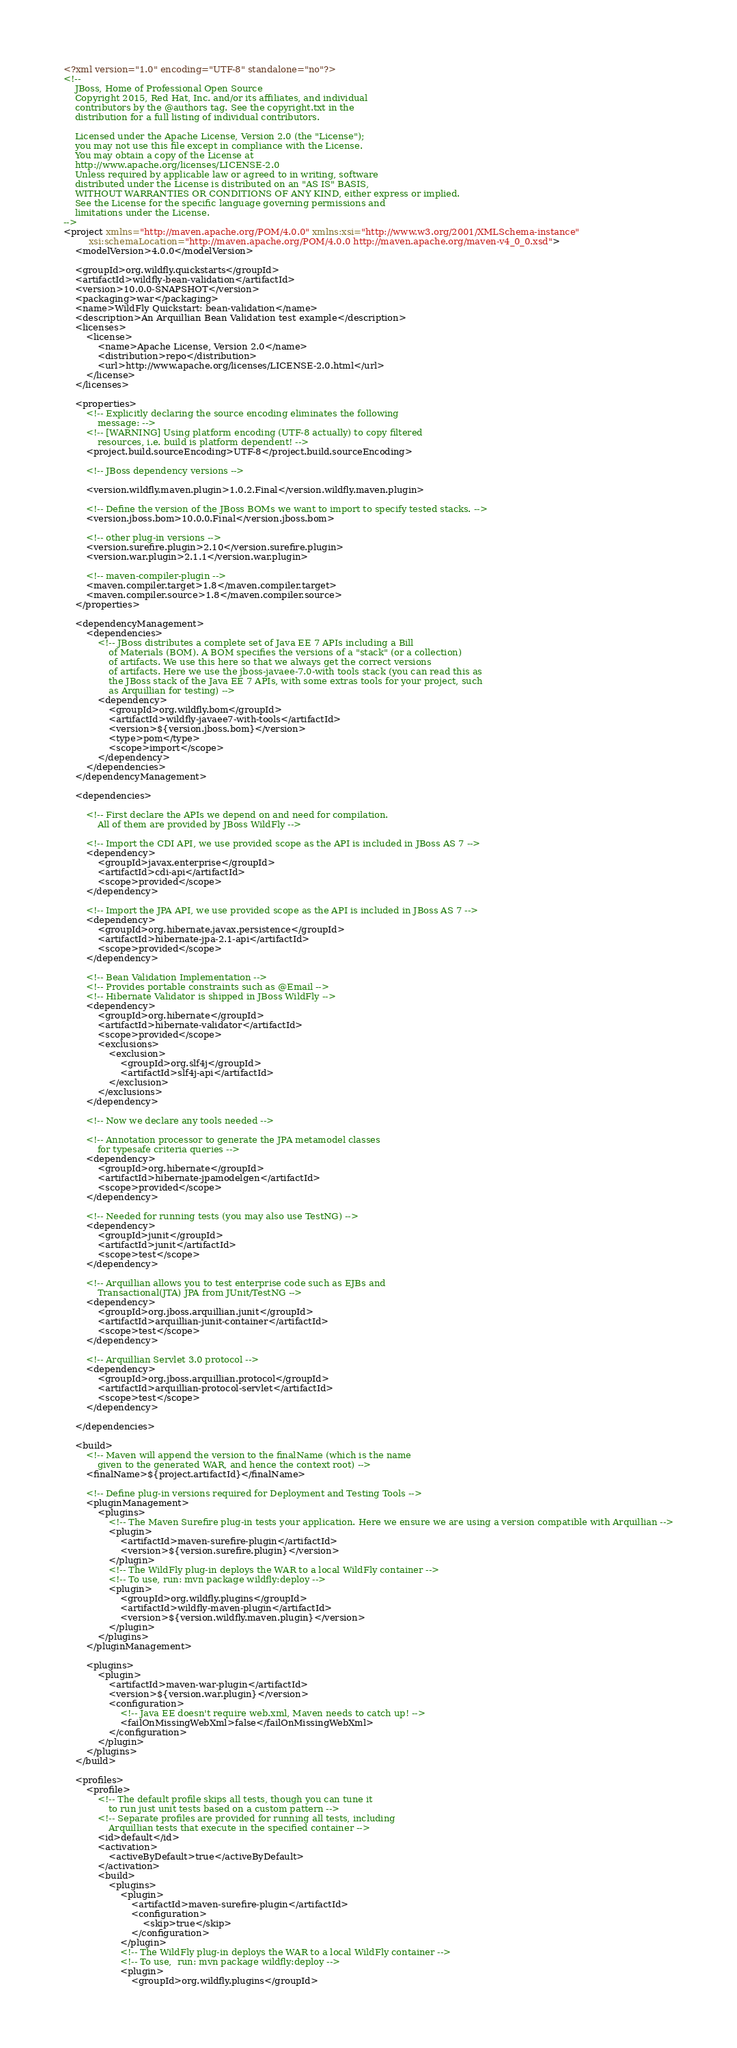<code> <loc_0><loc_0><loc_500><loc_500><_XML_><?xml version="1.0" encoding="UTF-8" standalone="no"?>
<!--
    JBoss, Home of Professional Open Source
    Copyright 2015, Red Hat, Inc. and/or its affiliates, and individual
    contributors by the @authors tag. See the copyright.txt in the
    distribution for a full listing of individual contributors.

    Licensed under the Apache License, Version 2.0 (the "License");
    you may not use this file except in compliance with the License.
    You may obtain a copy of the License at
    http://www.apache.org/licenses/LICENSE-2.0
    Unless required by applicable law or agreed to in writing, software
    distributed under the License is distributed on an "AS IS" BASIS,
    WITHOUT WARRANTIES OR CONDITIONS OF ANY KIND, either express or implied.
    See the License for the specific language governing permissions and
    limitations under the License.
-->
<project xmlns="http://maven.apache.org/POM/4.0.0" xmlns:xsi="http://www.w3.org/2001/XMLSchema-instance"
         xsi:schemaLocation="http://maven.apache.org/POM/4.0.0 http://maven.apache.org/maven-v4_0_0.xsd">
    <modelVersion>4.0.0</modelVersion>

    <groupId>org.wildfly.quickstarts</groupId>
    <artifactId>wildfly-bean-validation</artifactId>
    <version>10.0.0-SNAPSHOT</version>
    <packaging>war</packaging>
    <name>WildFly Quickstart: bean-validation</name>
    <description>An Arquillian Bean Validation test example</description>
    <licenses>
        <license>
            <name>Apache License, Version 2.0</name>
            <distribution>repo</distribution>
            <url>http://www.apache.org/licenses/LICENSE-2.0.html</url>
        </license>
    </licenses>

    <properties>
        <!-- Explicitly declaring the source encoding eliminates the following
            message: -->
        <!-- [WARNING] Using platform encoding (UTF-8 actually) to copy filtered
            resources, i.e. build is platform dependent! -->
        <project.build.sourceEncoding>UTF-8</project.build.sourceEncoding>

        <!-- JBoss dependency versions -->

        <version.wildfly.maven.plugin>1.0.2.Final</version.wildfly.maven.plugin>

        <!-- Define the version of the JBoss BOMs we want to import to specify tested stacks. -->
        <version.jboss.bom>10.0.0.Final</version.jboss.bom>

        <!-- other plug-in versions -->
        <version.surefire.plugin>2.10</version.surefire.plugin>
        <version.war.plugin>2.1.1</version.war.plugin>

        <!-- maven-compiler-plugin -->
        <maven.compiler.target>1.8</maven.compiler.target>
        <maven.compiler.source>1.8</maven.compiler.source>
    </properties>

    <dependencyManagement>
        <dependencies>
            <!-- JBoss distributes a complete set of Java EE 7 APIs including a Bill
                of Materials (BOM). A BOM specifies the versions of a "stack" (or a collection)
                of artifacts. We use this here so that we always get the correct versions
                of artifacts. Here we use the jboss-javaee-7.0-with tools stack (you can read this as
                the JBoss stack of the Java EE 7 APIs, with some extras tools for your project, such
                as Arquillian for testing) -->
            <dependency>
                <groupId>org.wildfly.bom</groupId>
                <artifactId>wildfly-javaee7-with-tools</artifactId>
                <version>${version.jboss.bom}</version>
                <type>pom</type>
                <scope>import</scope>
            </dependency>
        </dependencies>
    </dependencyManagement>

    <dependencies>

        <!-- First declare the APIs we depend on and need for compilation.
            All of them are provided by JBoss WildFly -->

        <!-- Import the CDI API, we use provided scope as the API is included in JBoss AS 7 -->
        <dependency>
            <groupId>javax.enterprise</groupId>
            <artifactId>cdi-api</artifactId>
            <scope>provided</scope>
        </dependency>

        <!-- Import the JPA API, we use provided scope as the API is included in JBoss AS 7 -->
        <dependency>
            <groupId>org.hibernate.javax.persistence</groupId>
            <artifactId>hibernate-jpa-2.1-api</artifactId>
            <scope>provided</scope>
        </dependency>

        <!-- Bean Validation Implementation -->
        <!-- Provides portable constraints such as @Email -->
        <!-- Hibernate Validator is shipped in JBoss WildFly -->
        <dependency>
            <groupId>org.hibernate</groupId>
            <artifactId>hibernate-validator</artifactId>
            <scope>provided</scope>
            <exclusions>
                <exclusion>
                    <groupId>org.slf4j</groupId>
                    <artifactId>slf4j-api</artifactId>
                </exclusion>
            </exclusions>
        </dependency>

        <!-- Now we declare any tools needed -->

        <!-- Annotation processor to generate the JPA metamodel classes
            for typesafe criteria queries -->
        <dependency>
            <groupId>org.hibernate</groupId>
            <artifactId>hibernate-jpamodelgen</artifactId>
            <scope>provided</scope>
        </dependency>

        <!-- Needed for running tests (you may also use TestNG) -->
        <dependency>
            <groupId>junit</groupId>
            <artifactId>junit</artifactId>
            <scope>test</scope>
        </dependency>

        <!-- Arquillian allows you to test enterprise code such as EJBs and
            Transactional(JTA) JPA from JUnit/TestNG -->
        <dependency>
            <groupId>org.jboss.arquillian.junit</groupId>
            <artifactId>arquillian-junit-container</artifactId>
            <scope>test</scope>
        </dependency>

        <!-- Arquillian Servlet 3.0 protocol -->
        <dependency>
            <groupId>org.jboss.arquillian.protocol</groupId>
            <artifactId>arquillian-protocol-servlet</artifactId>
            <scope>test</scope>
        </dependency>

    </dependencies>

    <build>
        <!-- Maven will append the version to the finalName (which is the name
            given to the generated WAR, and hence the context root) -->
        <finalName>${project.artifactId}</finalName>

        <!-- Define plug-in versions required for Deployment and Testing Tools -->
        <pluginManagement>
            <plugins>
                <!-- The Maven Surefire plug-in tests your application. Here we ensure we are using a version compatible with Arquillian -->
                <plugin>
                    <artifactId>maven-surefire-plugin</artifactId>
                    <version>${version.surefire.plugin}</version>
                </plugin>
                <!-- The WildFly plug-in deploys the WAR to a local WildFly container -->
                <!-- To use, run: mvn package wildfly:deploy -->
                <plugin>
                    <groupId>org.wildfly.plugins</groupId>
                    <artifactId>wildfly-maven-plugin</artifactId>
                    <version>${version.wildfly.maven.plugin}</version>
                </plugin>
            </plugins>
        </pluginManagement>

        <plugins>
            <plugin>
                <artifactId>maven-war-plugin</artifactId>
                <version>${version.war.plugin}</version>
                <configuration>
                    <!-- Java EE doesn't require web.xml, Maven needs to catch up! -->
                    <failOnMissingWebXml>false</failOnMissingWebXml>
                </configuration>
            </plugin>
        </plugins>
    </build>

    <profiles>
        <profile>
            <!-- The default profile skips all tests, though you can tune it
                to run just unit tests based on a custom pattern -->
            <!-- Separate profiles are provided for running all tests, including
                Arquillian tests that execute in the specified container -->
            <id>default</id>
            <activation>
                <activeByDefault>true</activeByDefault>
            </activation>
            <build>
                <plugins>
                    <plugin>
                        <artifactId>maven-surefire-plugin</artifactId>
                        <configuration>
                            <skip>true</skip>
                        </configuration>
                    </plugin>
                    <!-- The WildFly plug-in deploys the WAR to a local WildFly container -->
                    <!-- To use,  run: mvn package wildfly:deploy -->
                    <plugin>
                        <groupId>org.wildfly.plugins</groupId></code> 